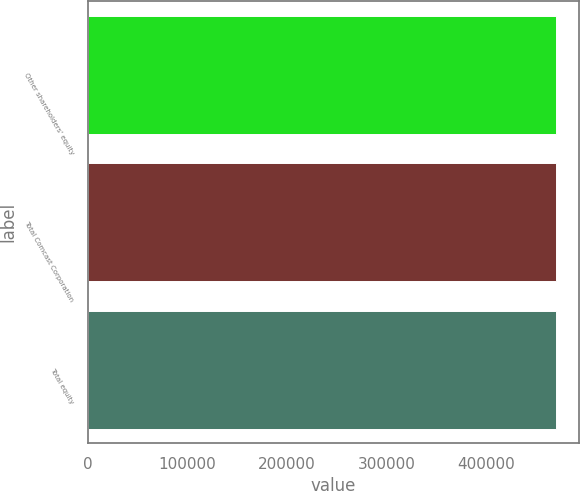Convert chart to OTSL. <chart><loc_0><loc_0><loc_500><loc_500><bar_chart><fcel>Other shareholders' equity<fcel>Total Comcast Corporation<fcel>Total equity<nl><fcel>469776<fcel>469776<fcel>469776<nl></chart> 